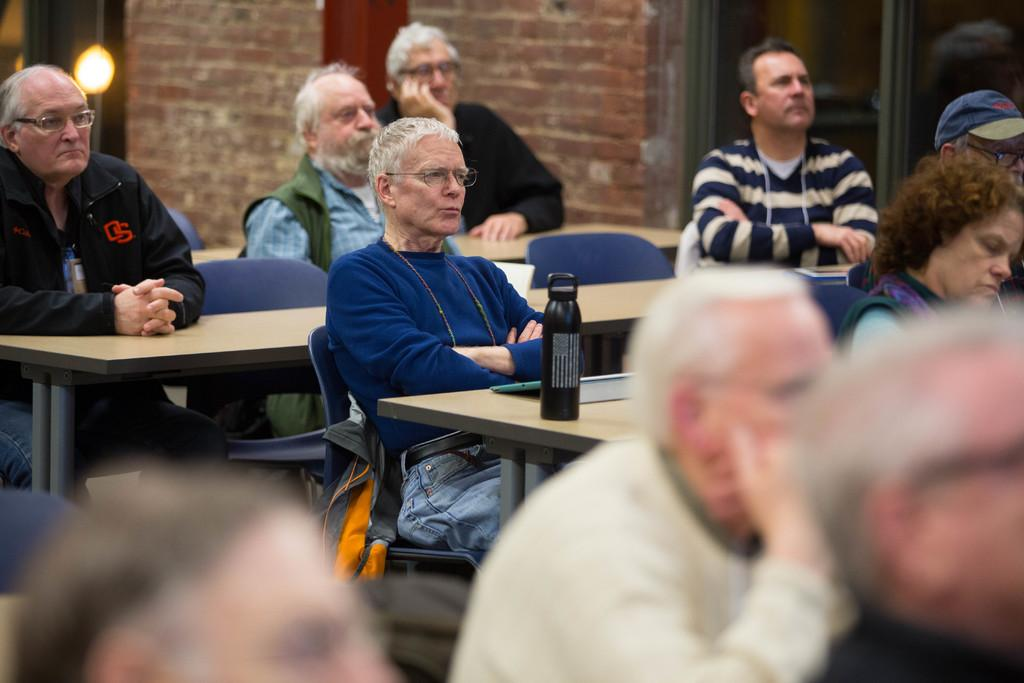What are the people in the image doing? The people in the image are sitting on chairs. What furniture is present in the image besides the chairs? There are tables in the image. What can be seen on the table? There is a bottle and an object on the table. What is visible in the background of the image? The background includes a wall, a light, and a glass. What type of plate is being used to hold the bursting tent in the image? There is no plate, bursting, or tent present in the image. 